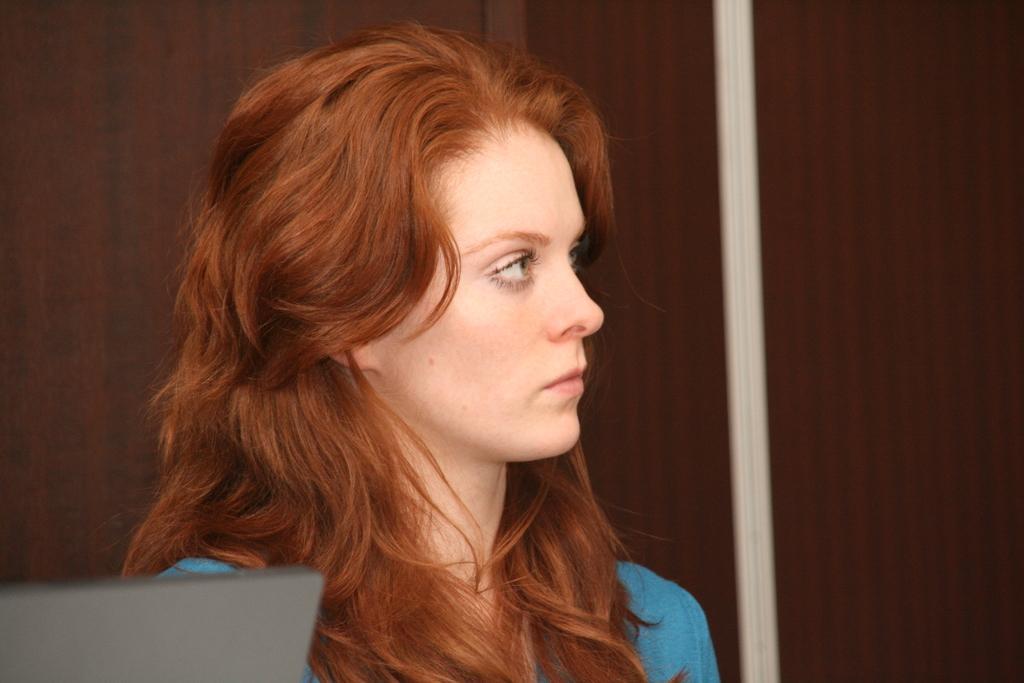Can you describe this image briefly? In this image in front there is a woman. Beside her there is some object. Behind her there is a wooden cupboard. 